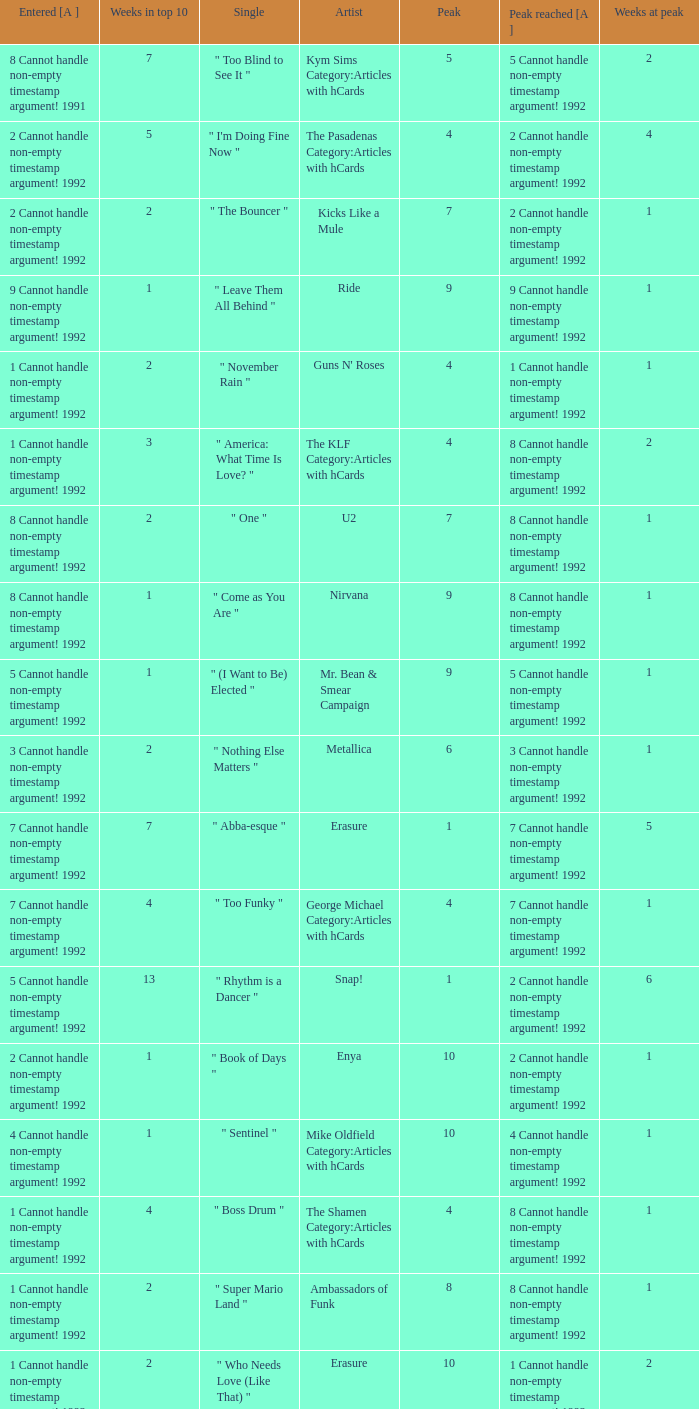What was the highest rank attained by a single that was in the top 10 for 4 weeks, entered at number 7, and had a non-empty timestamp argument in 1992? 7 Cannot handle non-empty timestamp argument! 1992. 